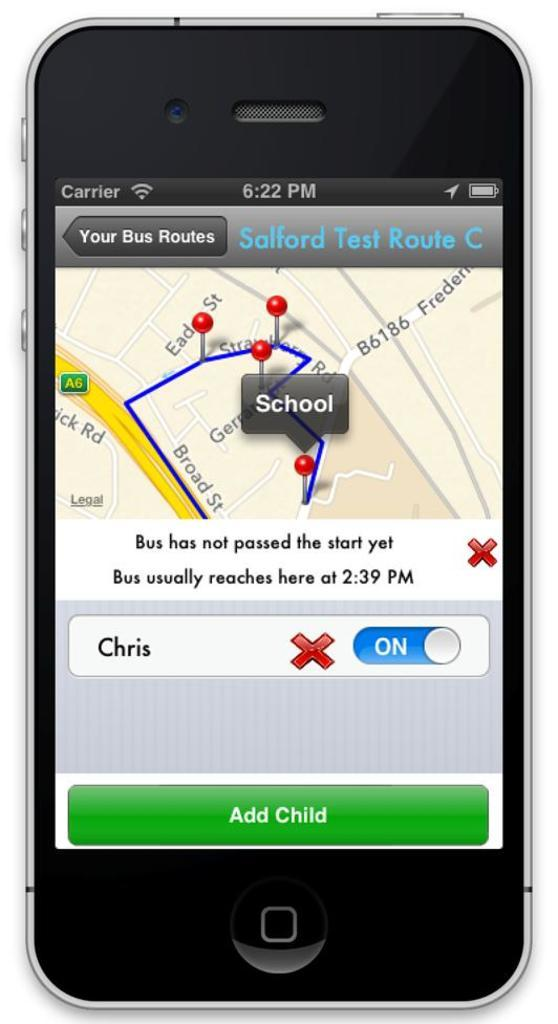Provide a one-sentence caption for the provided image. Phone screen showing different bus routes for children. 